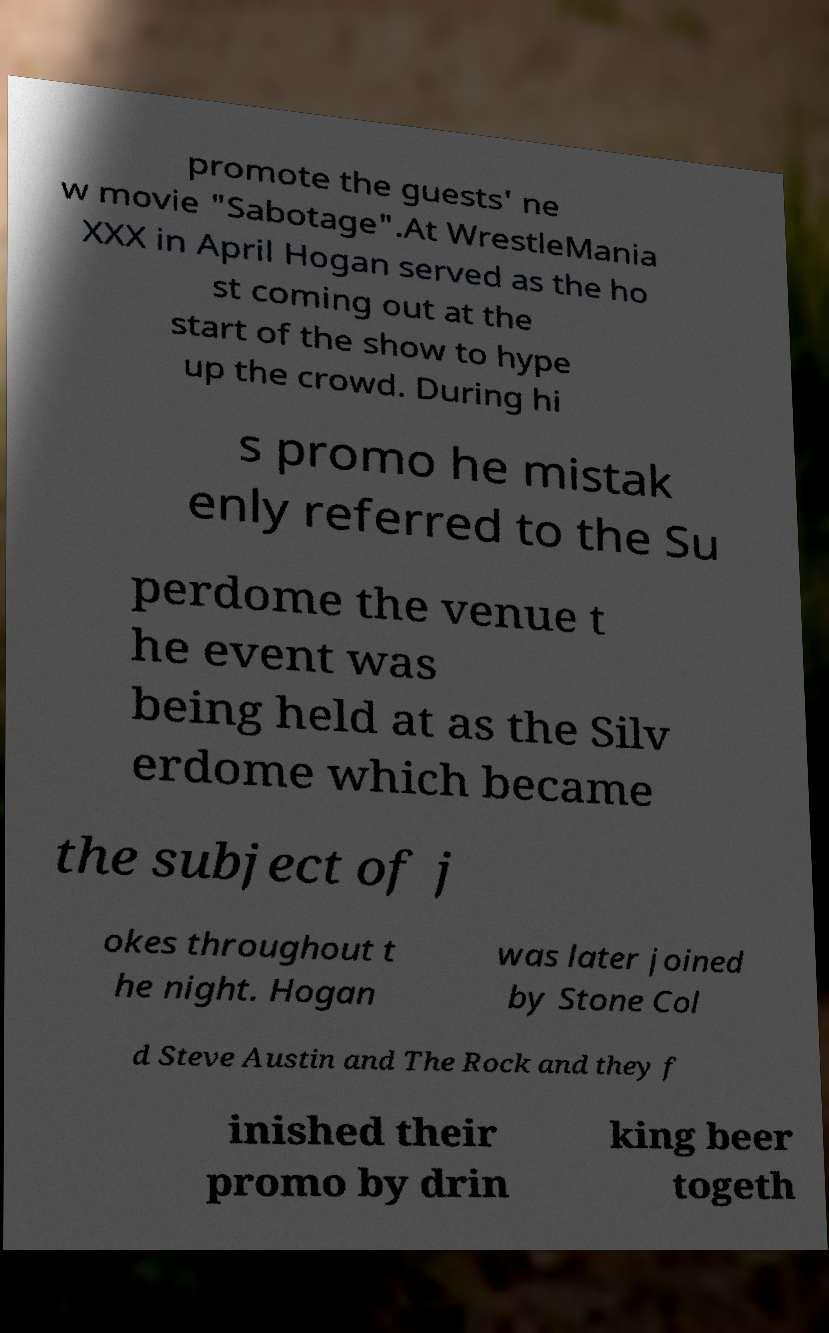Please read and relay the text visible in this image. What does it say? promote the guests' ne w movie "Sabotage".At WrestleMania XXX in April Hogan served as the ho st coming out at the start of the show to hype up the crowd. During hi s promo he mistak enly referred to the Su perdome the venue t he event was being held at as the Silv erdome which became the subject of j okes throughout t he night. Hogan was later joined by Stone Col d Steve Austin and The Rock and they f inished their promo by drin king beer togeth 